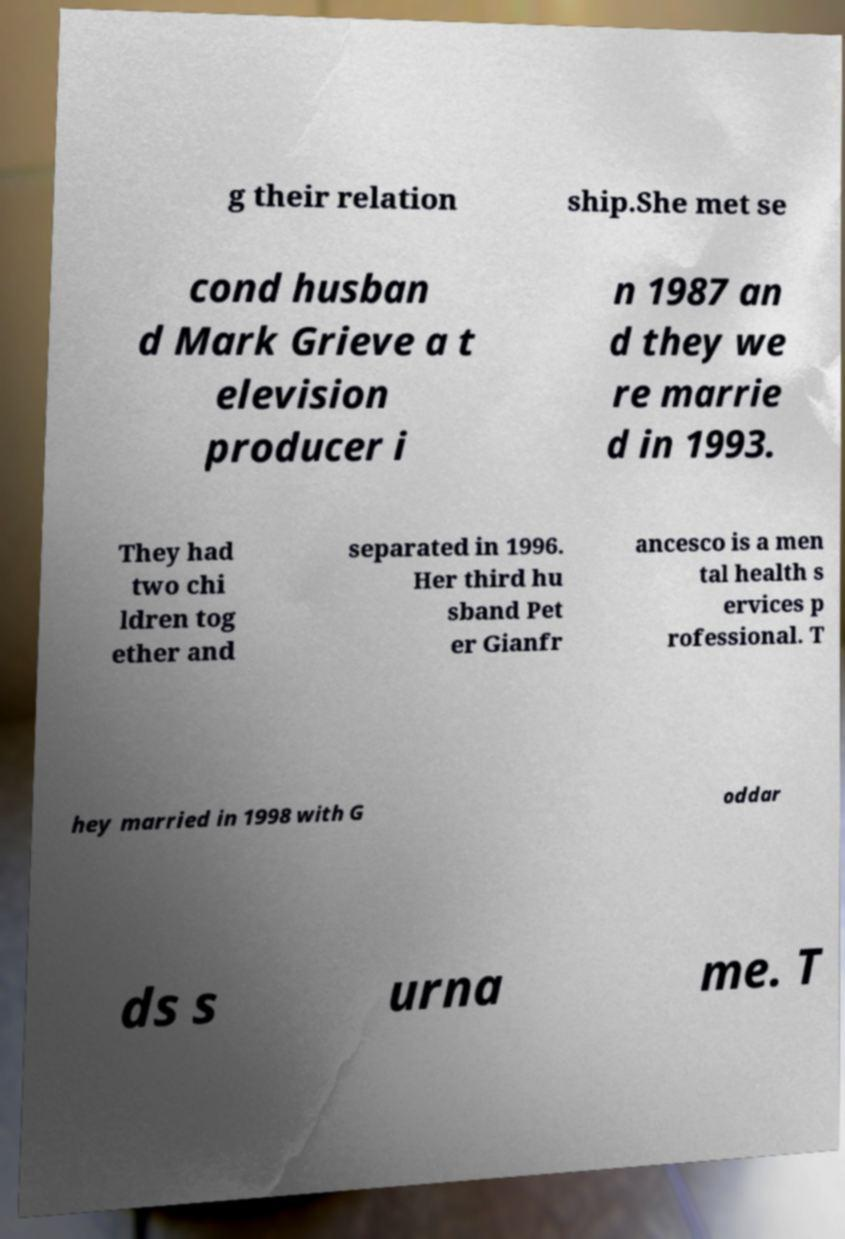I need the written content from this picture converted into text. Can you do that? g their relation ship.She met se cond husban d Mark Grieve a t elevision producer i n 1987 an d they we re marrie d in 1993. They had two chi ldren tog ether and separated in 1996. Her third hu sband Pet er Gianfr ancesco is a men tal health s ervices p rofessional. T hey married in 1998 with G oddar ds s urna me. T 